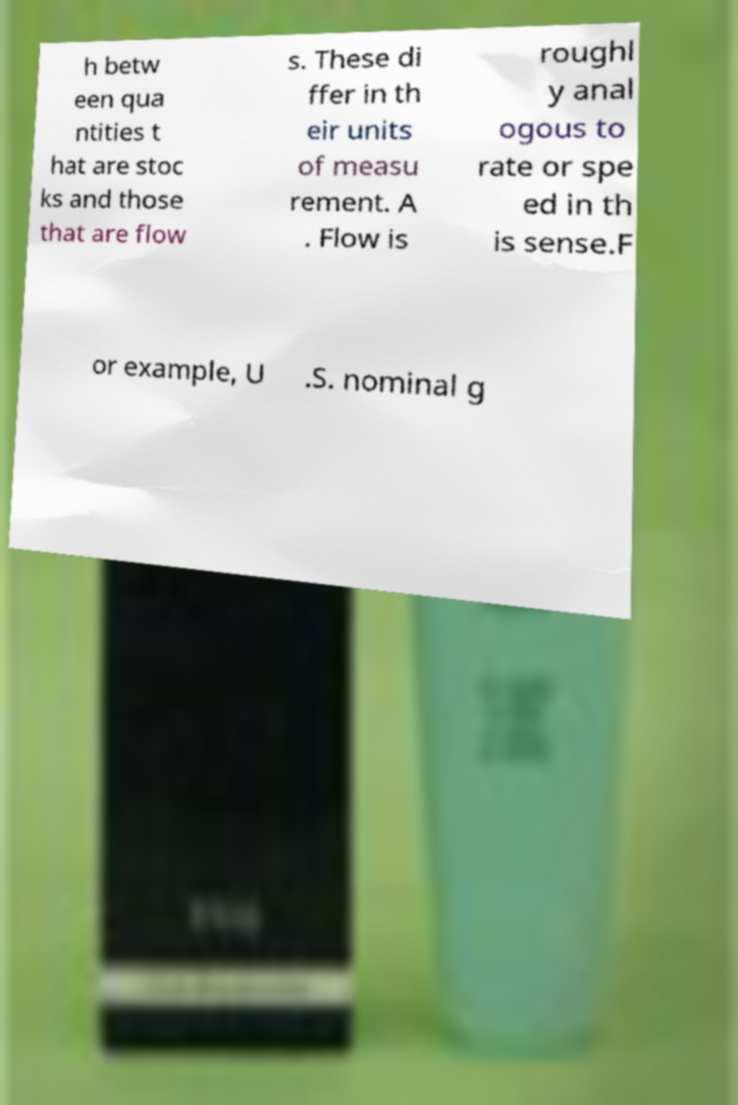Can you read and provide the text displayed in the image?This photo seems to have some interesting text. Can you extract and type it out for me? h betw een qua ntities t hat are stoc ks and those that are flow s. These di ffer in th eir units of measu rement. A . Flow is roughl y anal ogous to rate or spe ed in th is sense.F or example, U .S. nominal g 